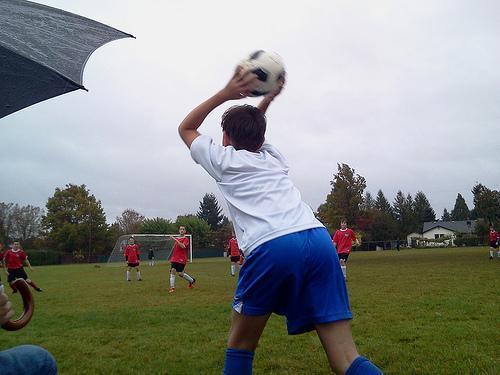How many balls are there?
Give a very brief answer. 1. 